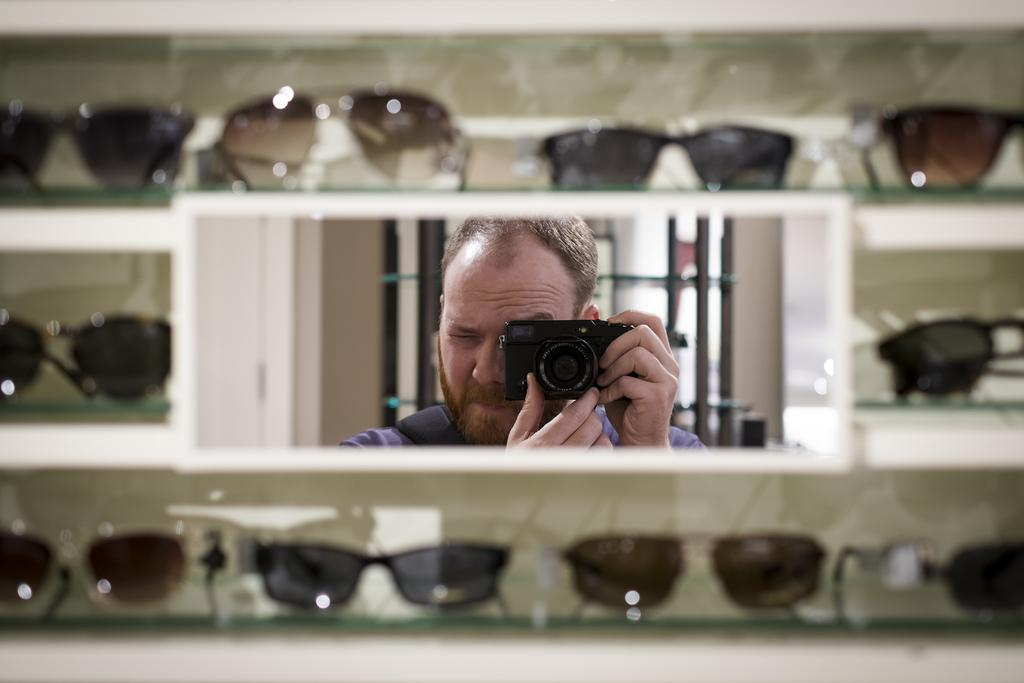Who is the person in the image? There is a man in the image. What is the man holding in the image? The man is holding a camera. Where is the man standing in the image? The man is standing behind a shelf. What items can be seen on the shelf? The shelf contains goggles. What type of land can be seen in the background of the image? There is no land visible in the image, as it primarily features a man holding a camera and standing behind a shelf with goggles. 